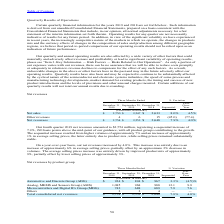According to Stmicroelectronics's financial document, What led to sequential increase in 2019? resulted from higher volumes of approximately 7% and an increase of approximately 1% in average selling prices, the latter entirely due to product mix, while selling prices remained substantially stable.. The document states: "ontributing to the growth. The sequential increase resulted from higher volumes of approximately 7% and an increase of approximately 1% in average sel..." Also, What led to increase in net revenues On a year-over-year basis? due to an increase of approximately 6% in average selling prices, partially offset by an approximate 2% decrease in volumes.. The document states: "nues increased by 4.0%. This increase was entirely due to an increase of approximately 6% in average selling prices, partially offset by an approximat..." Also, What led to increase in average selling price on a year-over-year basis? driven by improved product mix of approximately 9%, partially offset by lower selling prices of approximately 3%.. The document states: ". The average selling prices increase was entirely driven by improved product mix of approximately 9%, partially offset by lower selling prices of app..." Also, can you calculate: What is the average Net sales for the period December 31, 2019 and 2018? To answer this question, I need to perform calculations using the financial data. The calculation is: (2,750+2,633) / 2, which equals 2691.5 (in millions). This is based on the information: "Net sales $ 2,750 $ 2,547 $ 2,633 8.0% 4.5% Net sales $ 2,750 $ 2,547 $ 2,633 8.0% 4.5%..." The key data points involved are: 2,633, 2,750. Also, can you calculate: What is the average other revenues sales for the period December 31, 2019 and 2018? To answer this question, I need to perform calculations using the financial data. The calculation is: (4+15) / 2, which equals 9.5 (in millions). This is based on the information: "Other revenues 4 6 15 (45.0) (77.4) Other revenues 4 6 15 (45.0) (77.4)..." The key data points involved are: 15, 4. Also, can you calculate: What is the average net revenues for the period December 31, 2019 and 2018? To answer this question, I need to perform calculations using the financial data. The calculation is: (2,754+2,648) / 2, which equals 2701 (in millions). This is based on the information: "Net revenues $ 2,754 $ 2,553 $ 2,648 7.9% 4.0% Net revenues $ 2,754 $ 2,553 $ 2,648 7.9% 4.0%..." The key data points involved are: 2,648, 2,754. 